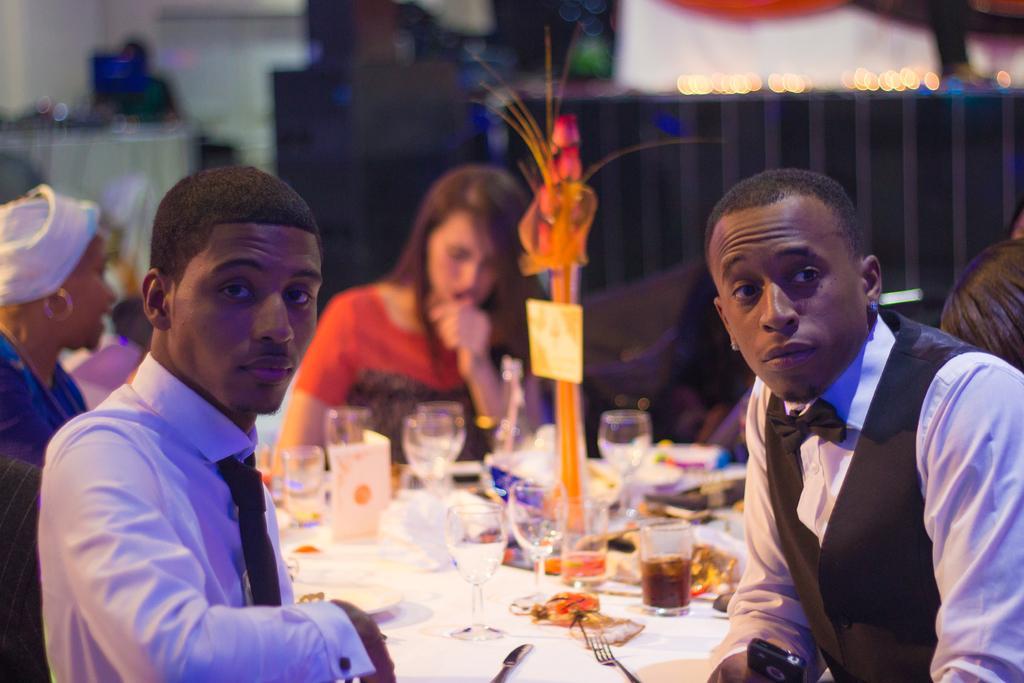Describe this image in one or two sentences. In this image I can see few people are sitting around this table. Here on this table I can see few glasses, a fork and a knife. 